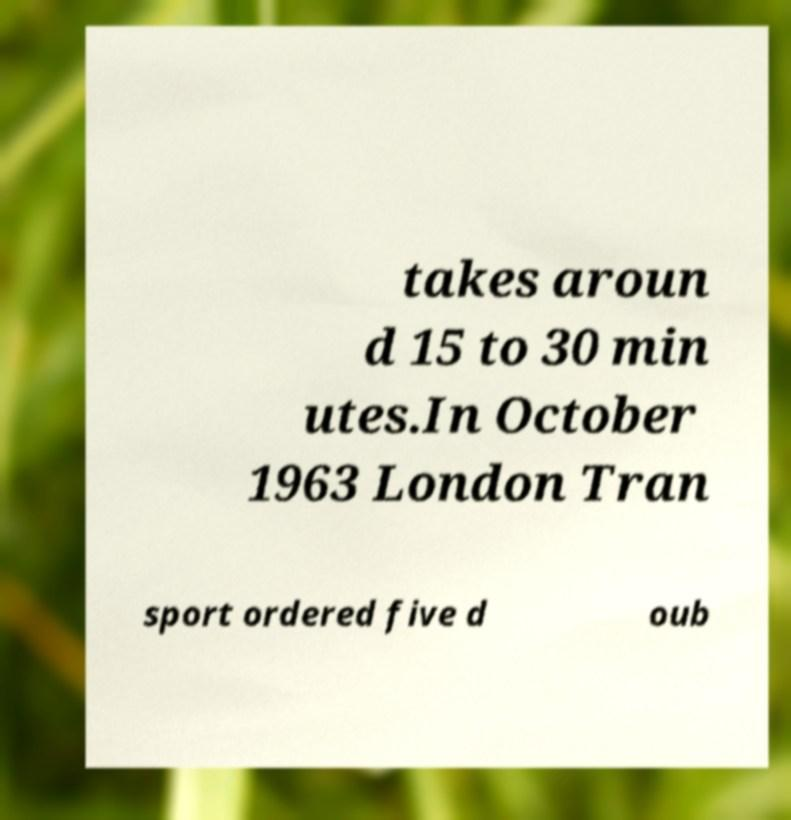Can you read and provide the text displayed in the image?This photo seems to have some interesting text. Can you extract and type it out for me? takes aroun d 15 to 30 min utes.In October 1963 London Tran sport ordered five d oub 